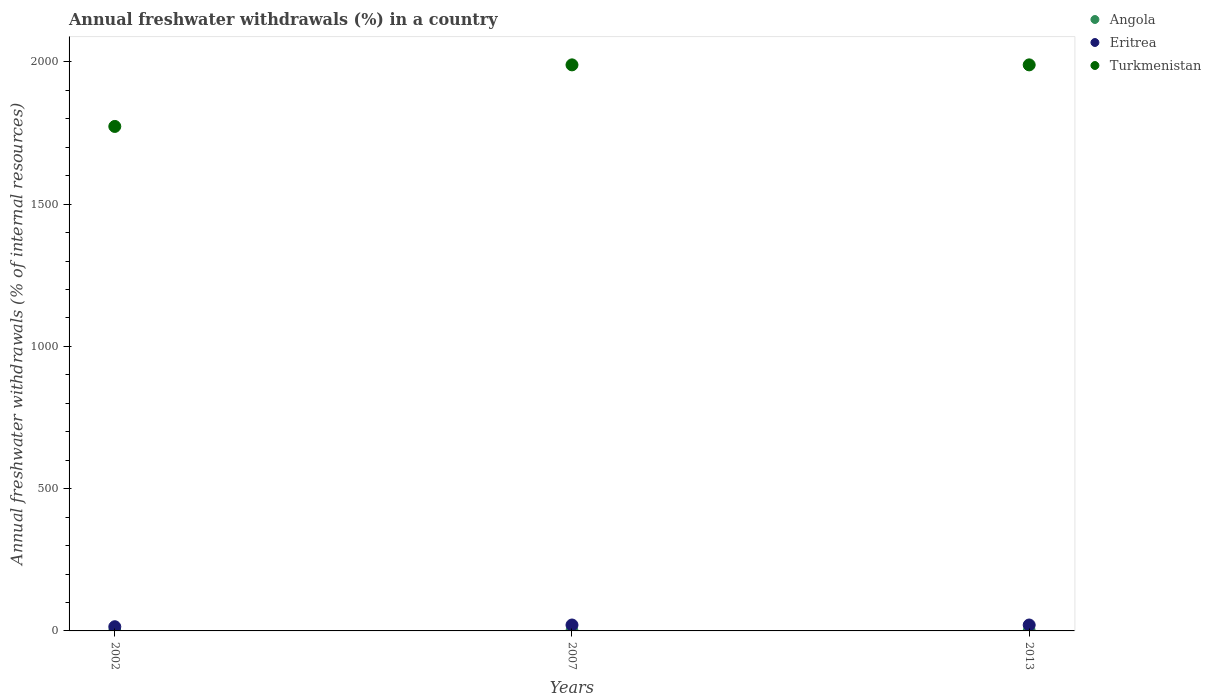What is the percentage of annual freshwater withdrawals in Turkmenistan in 2013?
Your answer should be compact. 1989.32. Across all years, what is the maximum percentage of annual freshwater withdrawals in Angola?
Give a very brief answer. 0.48. Across all years, what is the minimum percentage of annual freshwater withdrawals in Turkmenistan?
Offer a terse response. 1772.95. In which year was the percentage of annual freshwater withdrawals in Turkmenistan maximum?
Offer a very short reply. 2007. What is the total percentage of annual freshwater withdrawals in Angola in the graph?
Provide a succinct answer. 1.39. What is the difference between the percentage of annual freshwater withdrawals in Turkmenistan in 2002 and that in 2013?
Offer a very short reply. -216.37. What is the difference between the percentage of annual freshwater withdrawals in Turkmenistan in 2013 and the percentage of annual freshwater withdrawals in Angola in 2007?
Your response must be concise. 1988.85. What is the average percentage of annual freshwater withdrawals in Eritrea per year?
Your answer should be compact. 18.78. In the year 2013, what is the difference between the percentage of annual freshwater withdrawals in Angola and percentage of annual freshwater withdrawals in Turkmenistan?
Give a very brief answer. -1988.85. What is the ratio of the percentage of annual freshwater withdrawals in Angola in 2002 to that in 2013?
Make the answer very short. 0.91. Is the percentage of annual freshwater withdrawals in Turkmenistan in 2002 less than that in 2007?
Provide a short and direct response. Yes. Is the difference between the percentage of annual freshwater withdrawals in Angola in 2002 and 2007 greater than the difference between the percentage of annual freshwater withdrawals in Turkmenistan in 2002 and 2007?
Make the answer very short. Yes. What is the difference between the highest and the second highest percentage of annual freshwater withdrawals in Angola?
Provide a succinct answer. 0. What is the difference between the highest and the lowest percentage of annual freshwater withdrawals in Eritrea?
Provide a succinct answer. 6.02. Is the sum of the percentage of annual freshwater withdrawals in Turkmenistan in 2002 and 2013 greater than the maximum percentage of annual freshwater withdrawals in Angola across all years?
Keep it short and to the point. Yes. Does the percentage of annual freshwater withdrawals in Eritrea monotonically increase over the years?
Your response must be concise. No. How many dotlines are there?
Make the answer very short. 3. What is the difference between two consecutive major ticks on the Y-axis?
Provide a short and direct response. 500. Are the values on the major ticks of Y-axis written in scientific E-notation?
Your answer should be very brief. No. Does the graph contain grids?
Offer a very short reply. No. Where does the legend appear in the graph?
Offer a very short reply. Top right. How many legend labels are there?
Keep it short and to the point. 3. How are the legend labels stacked?
Offer a very short reply. Vertical. What is the title of the graph?
Keep it short and to the point. Annual freshwater withdrawals (%) in a country. Does "Nigeria" appear as one of the legend labels in the graph?
Provide a short and direct response. No. What is the label or title of the X-axis?
Ensure brevity in your answer.  Years. What is the label or title of the Y-axis?
Keep it short and to the point. Annual freshwater withdrawals (% of internal resources). What is the Annual freshwater withdrawals (% of internal resources) in Angola in 2002?
Offer a terse response. 0.43. What is the Annual freshwater withdrawals (% of internal resources) in Eritrea in 2002?
Ensure brevity in your answer.  14.76. What is the Annual freshwater withdrawals (% of internal resources) of Turkmenistan in 2002?
Offer a terse response. 1772.95. What is the Annual freshwater withdrawals (% of internal resources) of Angola in 2007?
Your answer should be compact. 0.48. What is the Annual freshwater withdrawals (% of internal resources) of Eritrea in 2007?
Your answer should be very brief. 20.79. What is the Annual freshwater withdrawals (% of internal resources) of Turkmenistan in 2007?
Your response must be concise. 1989.32. What is the Annual freshwater withdrawals (% of internal resources) in Angola in 2013?
Keep it short and to the point. 0.48. What is the Annual freshwater withdrawals (% of internal resources) of Eritrea in 2013?
Keep it short and to the point. 20.79. What is the Annual freshwater withdrawals (% of internal resources) of Turkmenistan in 2013?
Offer a very short reply. 1989.32. Across all years, what is the maximum Annual freshwater withdrawals (% of internal resources) of Angola?
Ensure brevity in your answer.  0.48. Across all years, what is the maximum Annual freshwater withdrawals (% of internal resources) in Eritrea?
Your response must be concise. 20.79. Across all years, what is the maximum Annual freshwater withdrawals (% of internal resources) in Turkmenistan?
Provide a succinct answer. 1989.32. Across all years, what is the minimum Annual freshwater withdrawals (% of internal resources) of Angola?
Your response must be concise. 0.43. Across all years, what is the minimum Annual freshwater withdrawals (% of internal resources) in Eritrea?
Keep it short and to the point. 14.76. Across all years, what is the minimum Annual freshwater withdrawals (% of internal resources) of Turkmenistan?
Your answer should be very brief. 1772.95. What is the total Annual freshwater withdrawals (% of internal resources) of Angola in the graph?
Give a very brief answer. 1.39. What is the total Annual freshwater withdrawals (% of internal resources) of Eritrea in the graph?
Your answer should be compact. 56.34. What is the total Annual freshwater withdrawals (% of internal resources) of Turkmenistan in the graph?
Your answer should be very brief. 5751.6. What is the difference between the Annual freshwater withdrawals (% of internal resources) of Angola in 2002 and that in 2007?
Your response must be concise. -0.04. What is the difference between the Annual freshwater withdrawals (% of internal resources) of Eritrea in 2002 and that in 2007?
Your response must be concise. -6.02. What is the difference between the Annual freshwater withdrawals (% of internal resources) in Turkmenistan in 2002 and that in 2007?
Keep it short and to the point. -216.37. What is the difference between the Annual freshwater withdrawals (% of internal resources) in Angola in 2002 and that in 2013?
Ensure brevity in your answer.  -0.04. What is the difference between the Annual freshwater withdrawals (% of internal resources) of Eritrea in 2002 and that in 2013?
Your answer should be compact. -6.02. What is the difference between the Annual freshwater withdrawals (% of internal resources) of Turkmenistan in 2002 and that in 2013?
Provide a short and direct response. -216.37. What is the difference between the Annual freshwater withdrawals (% of internal resources) in Eritrea in 2007 and that in 2013?
Your answer should be very brief. 0. What is the difference between the Annual freshwater withdrawals (% of internal resources) of Angola in 2002 and the Annual freshwater withdrawals (% of internal resources) of Eritrea in 2007?
Provide a succinct answer. -20.35. What is the difference between the Annual freshwater withdrawals (% of internal resources) of Angola in 2002 and the Annual freshwater withdrawals (% of internal resources) of Turkmenistan in 2007?
Keep it short and to the point. -1988.89. What is the difference between the Annual freshwater withdrawals (% of internal resources) of Eritrea in 2002 and the Annual freshwater withdrawals (% of internal resources) of Turkmenistan in 2007?
Keep it short and to the point. -1974.56. What is the difference between the Annual freshwater withdrawals (% of internal resources) in Angola in 2002 and the Annual freshwater withdrawals (% of internal resources) in Eritrea in 2013?
Your response must be concise. -20.35. What is the difference between the Annual freshwater withdrawals (% of internal resources) in Angola in 2002 and the Annual freshwater withdrawals (% of internal resources) in Turkmenistan in 2013?
Provide a short and direct response. -1988.89. What is the difference between the Annual freshwater withdrawals (% of internal resources) of Eritrea in 2002 and the Annual freshwater withdrawals (% of internal resources) of Turkmenistan in 2013?
Make the answer very short. -1974.56. What is the difference between the Annual freshwater withdrawals (% of internal resources) of Angola in 2007 and the Annual freshwater withdrawals (% of internal resources) of Eritrea in 2013?
Offer a terse response. -20.31. What is the difference between the Annual freshwater withdrawals (% of internal resources) in Angola in 2007 and the Annual freshwater withdrawals (% of internal resources) in Turkmenistan in 2013?
Your response must be concise. -1988.85. What is the difference between the Annual freshwater withdrawals (% of internal resources) of Eritrea in 2007 and the Annual freshwater withdrawals (% of internal resources) of Turkmenistan in 2013?
Keep it short and to the point. -1968.54. What is the average Annual freshwater withdrawals (% of internal resources) in Angola per year?
Ensure brevity in your answer.  0.46. What is the average Annual freshwater withdrawals (% of internal resources) of Eritrea per year?
Ensure brevity in your answer.  18.78. What is the average Annual freshwater withdrawals (% of internal resources) of Turkmenistan per year?
Provide a short and direct response. 1917.2. In the year 2002, what is the difference between the Annual freshwater withdrawals (% of internal resources) in Angola and Annual freshwater withdrawals (% of internal resources) in Eritrea?
Keep it short and to the point. -14.33. In the year 2002, what is the difference between the Annual freshwater withdrawals (% of internal resources) in Angola and Annual freshwater withdrawals (% of internal resources) in Turkmenistan?
Your answer should be very brief. -1772.52. In the year 2002, what is the difference between the Annual freshwater withdrawals (% of internal resources) in Eritrea and Annual freshwater withdrawals (% of internal resources) in Turkmenistan?
Offer a terse response. -1758.19. In the year 2007, what is the difference between the Annual freshwater withdrawals (% of internal resources) in Angola and Annual freshwater withdrawals (% of internal resources) in Eritrea?
Give a very brief answer. -20.31. In the year 2007, what is the difference between the Annual freshwater withdrawals (% of internal resources) in Angola and Annual freshwater withdrawals (% of internal resources) in Turkmenistan?
Make the answer very short. -1988.85. In the year 2007, what is the difference between the Annual freshwater withdrawals (% of internal resources) in Eritrea and Annual freshwater withdrawals (% of internal resources) in Turkmenistan?
Provide a short and direct response. -1968.54. In the year 2013, what is the difference between the Annual freshwater withdrawals (% of internal resources) of Angola and Annual freshwater withdrawals (% of internal resources) of Eritrea?
Give a very brief answer. -20.31. In the year 2013, what is the difference between the Annual freshwater withdrawals (% of internal resources) in Angola and Annual freshwater withdrawals (% of internal resources) in Turkmenistan?
Your response must be concise. -1988.85. In the year 2013, what is the difference between the Annual freshwater withdrawals (% of internal resources) in Eritrea and Annual freshwater withdrawals (% of internal resources) in Turkmenistan?
Make the answer very short. -1968.54. What is the ratio of the Annual freshwater withdrawals (% of internal resources) in Angola in 2002 to that in 2007?
Provide a short and direct response. 0.91. What is the ratio of the Annual freshwater withdrawals (% of internal resources) in Eritrea in 2002 to that in 2007?
Make the answer very short. 0.71. What is the ratio of the Annual freshwater withdrawals (% of internal resources) in Turkmenistan in 2002 to that in 2007?
Your answer should be very brief. 0.89. What is the ratio of the Annual freshwater withdrawals (% of internal resources) of Angola in 2002 to that in 2013?
Your response must be concise. 0.91. What is the ratio of the Annual freshwater withdrawals (% of internal resources) of Eritrea in 2002 to that in 2013?
Your answer should be compact. 0.71. What is the ratio of the Annual freshwater withdrawals (% of internal resources) in Turkmenistan in 2002 to that in 2013?
Your answer should be compact. 0.89. What is the difference between the highest and the second highest Annual freshwater withdrawals (% of internal resources) in Angola?
Provide a short and direct response. 0. What is the difference between the highest and the second highest Annual freshwater withdrawals (% of internal resources) of Turkmenistan?
Your answer should be very brief. 0. What is the difference between the highest and the lowest Annual freshwater withdrawals (% of internal resources) in Angola?
Your answer should be compact. 0.04. What is the difference between the highest and the lowest Annual freshwater withdrawals (% of internal resources) in Eritrea?
Your answer should be compact. 6.02. What is the difference between the highest and the lowest Annual freshwater withdrawals (% of internal resources) of Turkmenistan?
Offer a very short reply. 216.37. 